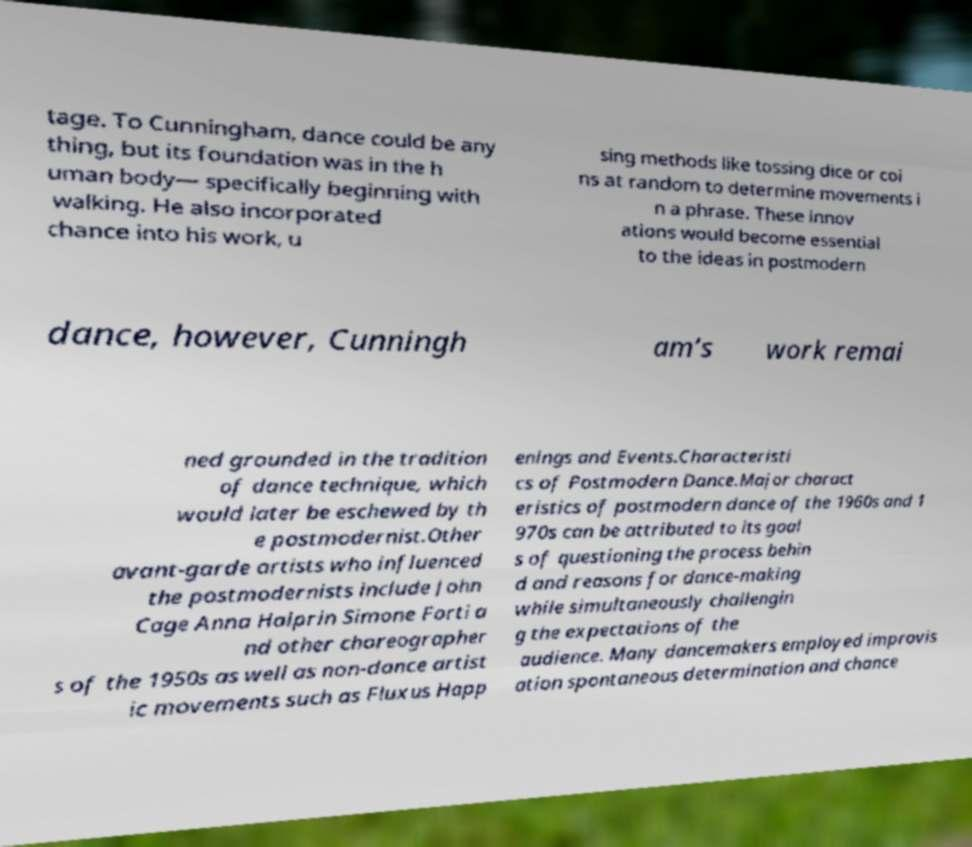Can you read and provide the text displayed in the image?This photo seems to have some interesting text. Can you extract and type it out for me? tage. To Cunningham, dance could be any thing, but its foundation was in the h uman body— specifically beginning with walking. He also incorporated chance into his work, u sing methods like tossing dice or coi ns at random to determine movements i n a phrase. These innov ations would become essential to the ideas in postmodern dance, however, Cunningh am’s work remai ned grounded in the tradition of dance technique, which would later be eschewed by th e postmodernist.Other avant-garde artists who influenced the postmodernists include John Cage Anna Halprin Simone Forti a nd other choreographer s of the 1950s as well as non-dance artist ic movements such as Fluxus Happ enings and Events.Characteristi cs of Postmodern Dance.Major charact eristics of postmodern dance of the 1960s and 1 970s can be attributed to its goal s of questioning the process behin d and reasons for dance-making while simultaneously challengin g the expectations of the audience. Many dancemakers employed improvis ation spontaneous determination and chance 